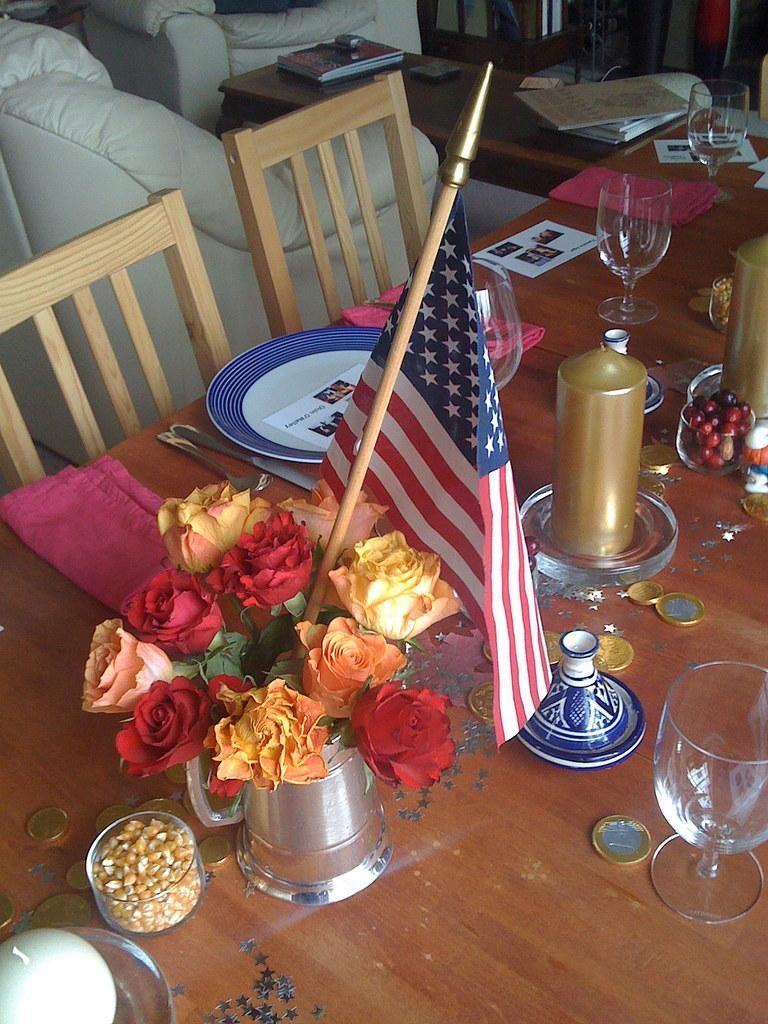Could you give a brief overview of what you see in this image? In this image we can see a flag and flowers in a jug, glasses, cards, plates, clothes, knives, coins, berries in a cup, maize seeds in a cup and other objects on the table. There are chairs, books and objects on a table. 